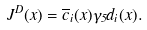<formula> <loc_0><loc_0><loc_500><loc_500>J ^ { D } ( x ) = \overline { c } _ { i } ( x ) \gamma _ { 5 } d _ { i } ( x ) .</formula> 